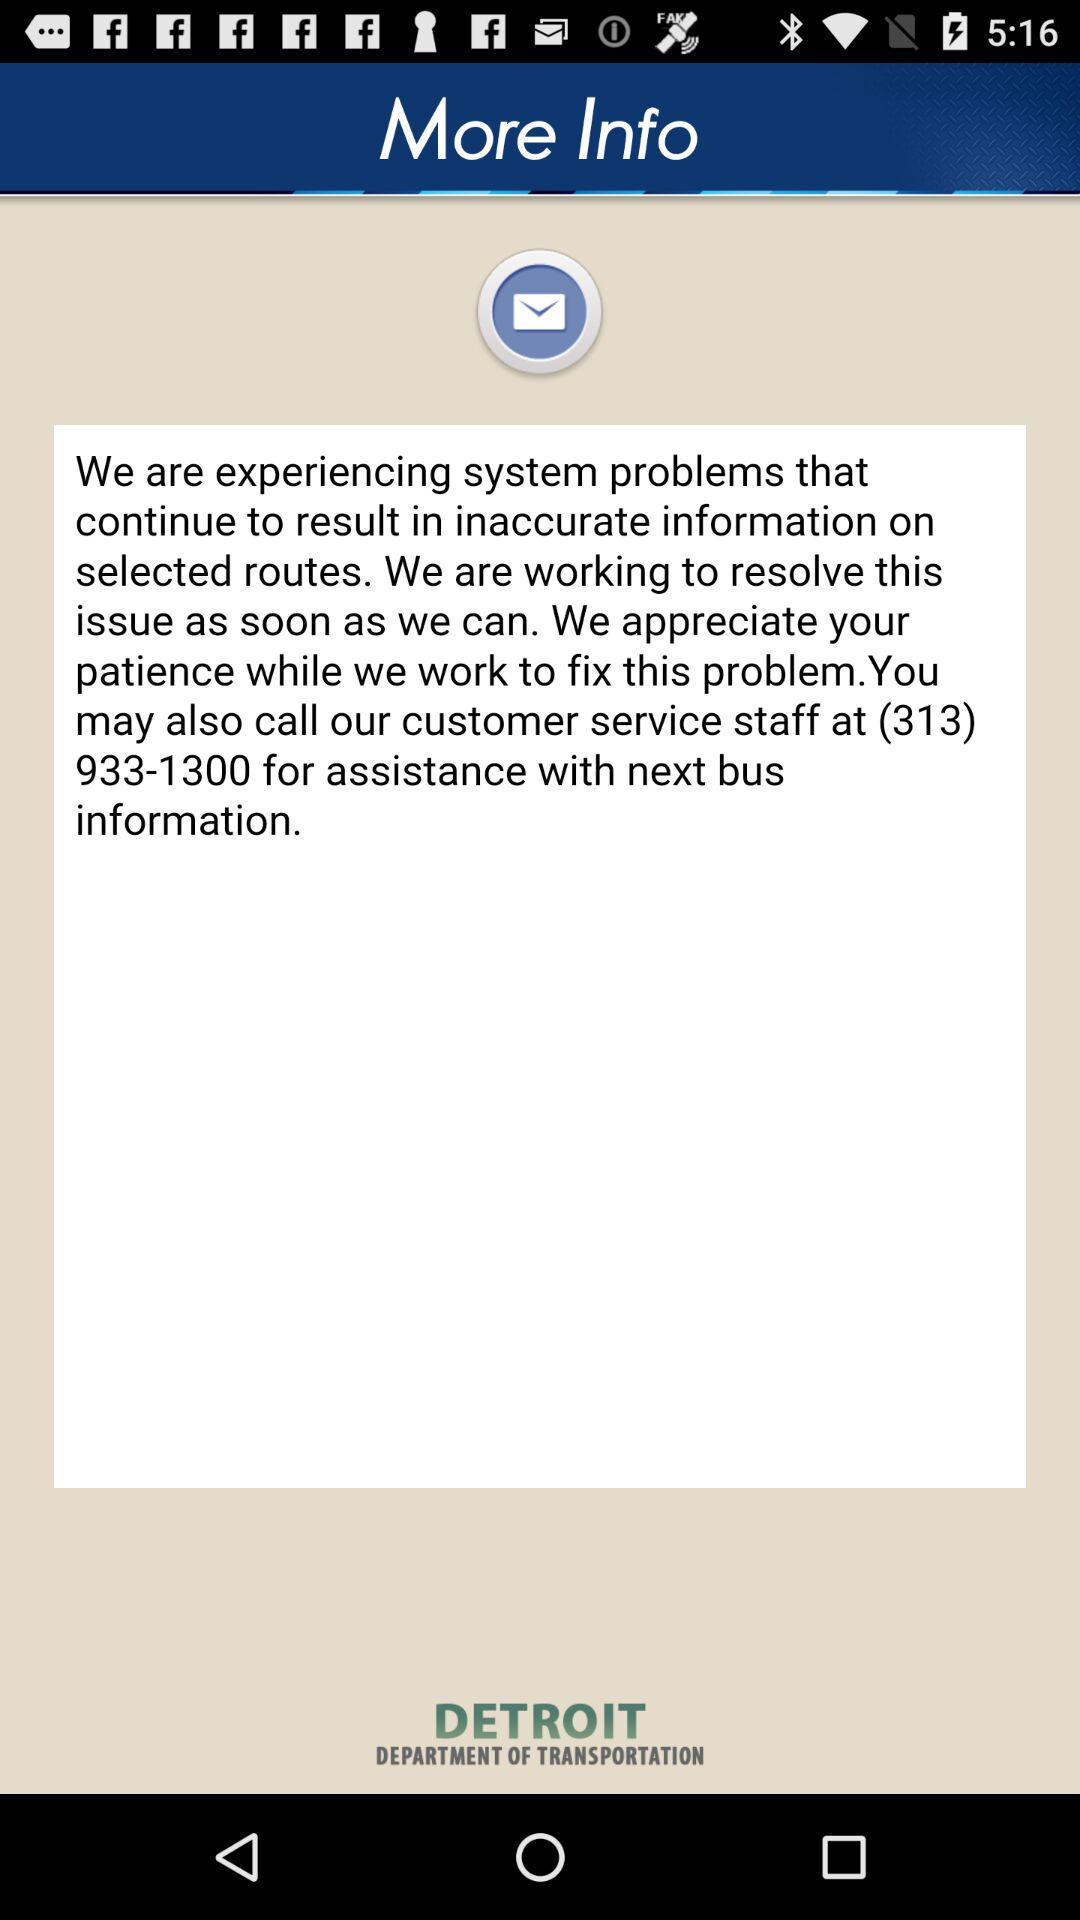Who is this application powered by?
When the provided information is insufficient, respond with <no answer>. <no answer> 